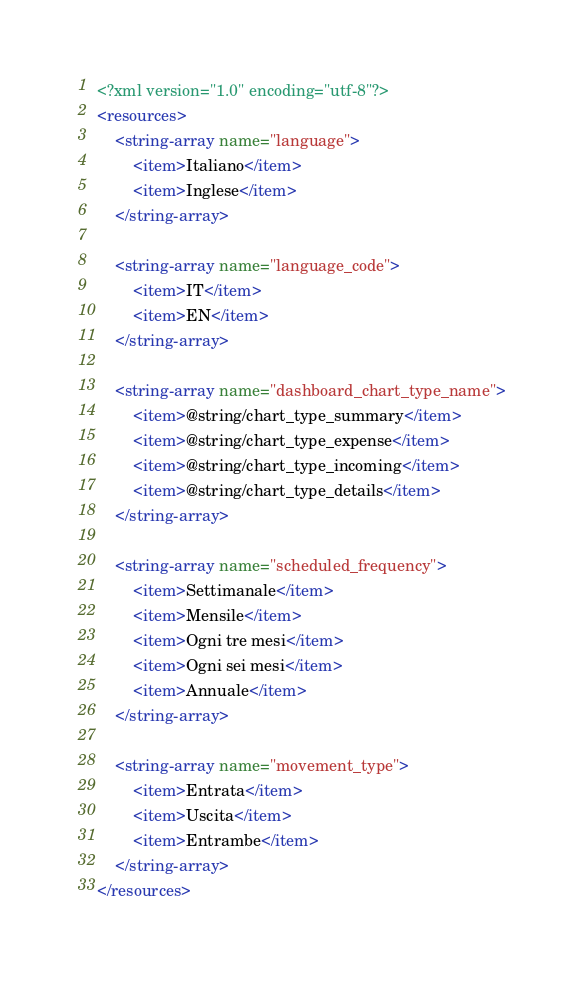<code> <loc_0><loc_0><loc_500><loc_500><_XML_><?xml version="1.0" encoding="utf-8"?>
<resources>
    <string-array name="language">
        <item>Italiano</item>
        <item>Inglese</item>
    </string-array>

    <string-array name="language_code">
        <item>IT</item>
        <item>EN</item>
    </string-array>

    <string-array name="dashboard_chart_type_name">
        <item>@string/chart_type_summary</item>
        <item>@string/chart_type_expense</item>
        <item>@string/chart_type_incoming</item>
        <item>@string/chart_type_details</item>
    </string-array>

    <string-array name="scheduled_frequency">
        <item>Settimanale</item>
        <item>Mensile</item>
        <item>Ogni tre mesi</item>
        <item>Ogni sei mesi</item>
        <item>Annuale</item>
    </string-array>

    <string-array name="movement_type">
        <item>Entrata</item>
        <item>Uscita</item>
        <item>Entrambe</item>
    </string-array>
</resources></code> 